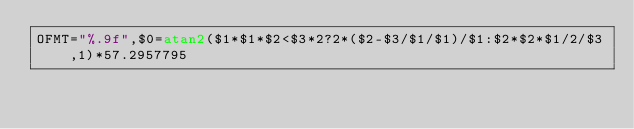Convert code to text. <code><loc_0><loc_0><loc_500><loc_500><_Awk_>OFMT="%.9f",$0=atan2($1*$1*$2<$3*2?2*($2-$3/$1/$1)/$1:$2*$2*$1/2/$3,1)*57.2957795</code> 